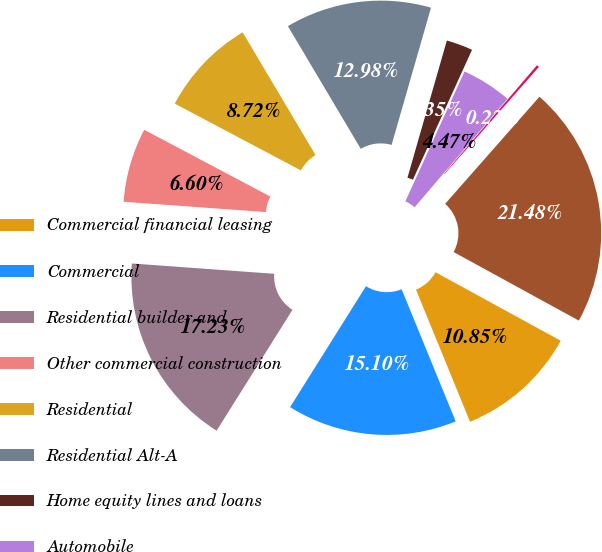Convert chart. <chart><loc_0><loc_0><loc_500><loc_500><pie_chart><fcel>Commercial financial leasing<fcel>Commercial<fcel>Residential builder and<fcel>Other commercial construction<fcel>Residential<fcel>Residential Alt-A<fcel>Home equity lines and loans<fcel>Automobile<fcel>Other<fcel>Total<nl><fcel>10.85%<fcel>15.1%<fcel>17.23%<fcel>6.6%<fcel>8.72%<fcel>12.98%<fcel>2.35%<fcel>4.47%<fcel>0.22%<fcel>21.48%<nl></chart> 